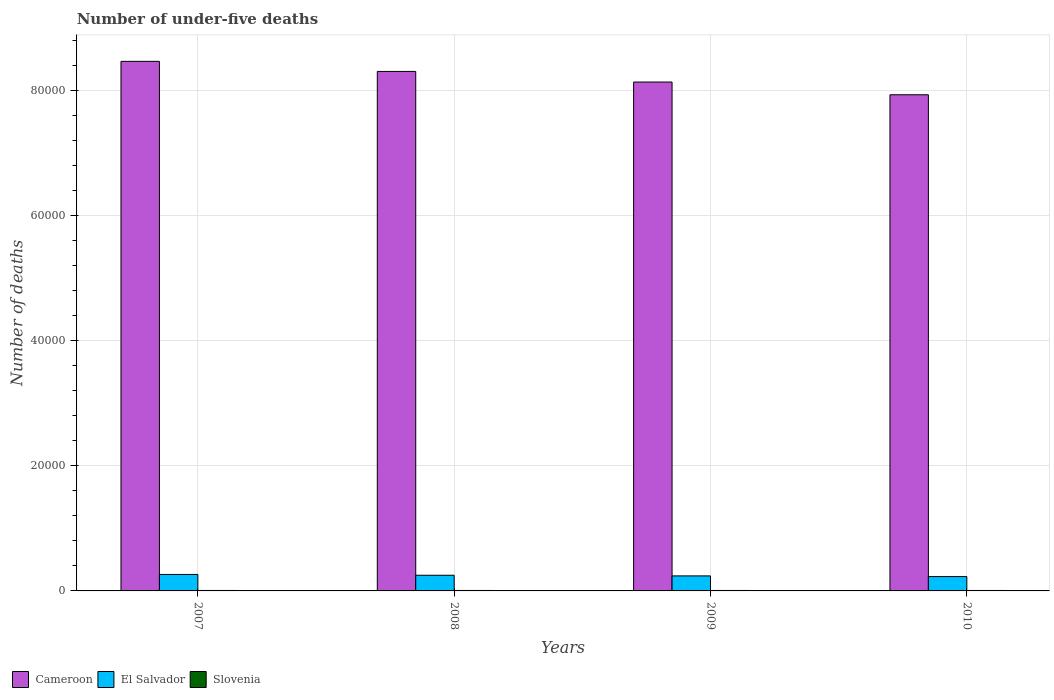How many different coloured bars are there?
Give a very brief answer. 3. How many groups of bars are there?
Your response must be concise. 4. Are the number of bars on each tick of the X-axis equal?
Give a very brief answer. Yes. How many bars are there on the 2nd tick from the left?
Provide a short and direct response. 3. What is the label of the 1st group of bars from the left?
Your response must be concise. 2007. In how many cases, is the number of bars for a given year not equal to the number of legend labels?
Give a very brief answer. 0. Across all years, what is the maximum number of under-five deaths in Cameroon?
Keep it short and to the point. 8.47e+04. Across all years, what is the minimum number of under-five deaths in Cameroon?
Provide a succinct answer. 7.93e+04. In which year was the number of under-five deaths in El Salvador maximum?
Provide a short and direct response. 2007. In which year was the number of under-five deaths in Slovenia minimum?
Provide a short and direct response. 2010. What is the total number of under-five deaths in Cameroon in the graph?
Ensure brevity in your answer.  3.28e+05. What is the difference between the number of under-five deaths in El Salvador in 2008 and that in 2009?
Your answer should be very brief. 103. What is the difference between the number of under-five deaths in Slovenia in 2010 and the number of under-five deaths in Cameroon in 2009?
Give a very brief answer. -8.13e+04. In the year 2009, what is the difference between the number of under-five deaths in El Salvador and number of under-five deaths in Cameroon?
Ensure brevity in your answer.  -7.90e+04. In how many years, is the number of under-five deaths in El Salvador greater than 56000?
Ensure brevity in your answer.  0. What is the ratio of the number of under-five deaths in El Salvador in 2007 to that in 2009?
Offer a very short reply. 1.1. Is the number of under-five deaths in Cameroon in 2008 less than that in 2010?
Your answer should be compact. No. Is the difference between the number of under-five deaths in El Salvador in 2009 and 2010 greater than the difference between the number of under-five deaths in Cameroon in 2009 and 2010?
Your answer should be compact. No. What is the difference between the highest and the second highest number of under-five deaths in Cameroon?
Offer a very short reply. 1611. What is the difference between the highest and the lowest number of under-five deaths in Cameroon?
Provide a short and direct response. 5342. What does the 3rd bar from the left in 2009 represents?
Make the answer very short. Slovenia. What does the 3rd bar from the right in 2010 represents?
Provide a short and direct response. Cameroon. How many bars are there?
Provide a short and direct response. 12. Are all the bars in the graph horizontal?
Your answer should be compact. No. What is the difference between two consecutive major ticks on the Y-axis?
Your answer should be very brief. 2.00e+04. Are the values on the major ticks of Y-axis written in scientific E-notation?
Make the answer very short. No. Does the graph contain any zero values?
Keep it short and to the point. No. Does the graph contain grids?
Your response must be concise. Yes. Where does the legend appear in the graph?
Offer a very short reply. Bottom left. How are the legend labels stacked?
Offer a very short reply. Horizontal. What is the title of the graph?
Provide a succinct answer. Number of under-five deaths. Does "Israel" appear as one of the legend labels in the graph?
Offer a terse response. No. What is the label or title of the X-axis?
Make the answer very short. Years. What is the label or title of the Y-axis?
Offer a terse response. Number of deaths. What is the Number of deaths in Cameroon in 2007?
Give a very brief answer. 8.47e+04. What is the Number of deaths in El Salvador in 2007?
Offer a terse response. 2633. What is the Number of deaths of Slovenia in 2007?
Provide a succinct answer. 73. What is the Number of deaths of Cameroon in 2008?
Provide a short and direct response. 8.31e+04. What is the Number of deaths in El Salvador in 2008?
Keep it short and to the point. 2505. What is the Number of deaths in Slovenia in 2008?
Keep it short and to the point. 73. What is the Number of deaths of Cameroon in 2009?
Provide a succinct answer. 8.14e+04. What is the Number of deaths in El Salvador in 2009?
Provide a short and direct response. 2402. What is the Number of deaths of Cameroon in 2010?
Ensure brevity in your answer.  7.93e+04. What is the Number of deaths of El Salvador in 2010?
Provide a short and direct response. 2291. Across all years, what is the maximum Number of deaths in Cameroon?
Provide a short and direct response. 8.47e+04. Across all years, what is the maximum Number of deaths in El Salvador?
Ensure brevity in your answer.  2633. Across all years, what is the maximum Number of deaths in Slovenia?
Make the answer very short. 74. Across all years, what is the minimum Number of deaths in Cameroon?
Your response must be concise. 7.93e+04. Across all years, what is the minimum Number of deaths of El Salvador?
Provide a succinct answer. 2291. What is the total Number of deaths of Cameroon in the graph?
Provide a short and direct response. 3.28e+05. What is the total Number of deaths in El Salvador in the graph?
Give a very brief answer. 9831. What is the total Number of deaths of Slovenia in the graph?
Your answer should be very brief. 292. What is the difference between the Number of deaths in Cameroon in 2007 and that in 2008?
Your response must be concise. 1611. What is the difference between the Number of deaths in El Salvador in 2007 and that in 2008?
Ensure brevity in your answer.  128. What is the difference between the Number of deaths in Slovenia in 2007 and that in 2008?
Keep it short and to the point. 0. What is the difference between the Number of deaths in Cameroon in 2007 and that in 2009?
Your answer should be very brief. 3306. What is the difference between the Number of deaths in El Salvador in 2007 and that in 2009?
Offer a very short reply. 231. What is the difference between the Number of deaths of Slovenia in 2007 and that in 2009?
Make the answer very short. -1. What is the difference between the Number of deaths of Cameroon in 2007 and that in 2010?
Keep it short and to the point. 5342. What is the difference between the Number of deaths of El Salvador in 2007 and that in 2010?
Your answer should be very brief. 342. What is the difference between the Number of deaths of Slovenia in 2007 and that in 2010?
Provide a short and direct response. 1. What is the difference between the Number of deaths in Cameroon in 2008 and that in 2009?
Your answer should be compact. 1695. What is the difference between the Number of deaths of El Salvador in 2008 and that in 2009?
Ensure brevity in your answer.  103. What is the difference between the Number of deaths of Slovenia in 2008 and that in 2009?
Give a very brief answer. -1. What is the difference between the Number of deaths of Cameroon in 2008 and that in 2010?
Ensure brevity in your answer.  3731. What is the difference between the Number of deaths in El Salvador in 2008 and that in 2010?
Offer a terse response. 214. What is the difference between the Number of deaths in Cameroon in 2009 and that in 2010?
Offer a terse response. 2036. What is the difference between the Number of deaths in El Salvador in 2009 and that in 2010?
Keep it short and to the point. 111. What is the difference between the Number of deaths in Slovenia in 2009 and that in 2010?
Ensure brevity in your answer.  2. What is the difference between the Number of deaths of Cameroon in 2007 and the Number of deaths of El Salvador in 2008?
Make the answer very short. 8.22e+04. What is the difference between the Number of deaths in Cameroon in 2007 and the Number of deaths in Slovenia in 2008?
Your answer should be compact. 8.46e+04. What is the difference between the Number of deaths of El Salvador in 2007 and the Number of deaths of Slovenia in 2008?
Give a very brief answer. 2560. What is the difference between the Number of deaths of Cameroon in 2007 and the Number of deaths of El Salvador in 2009?
Provide a short and direct response. 8.23e+04. What is the difference between the Number of deaths of Cameroon in 2007 and the Number of deaths of Slovenia in 2009?
Give a very brief answer. 8.46e+04. What is the difference between the Number of deaths in El Salvador in 2007 and the Number of deaths in Slovenia in 2009?
Offer a terse response. 2559. What is the difference between the Number of deaths in Cameroon in 2007 and the Number of deaths in El Salvador in 2010?
Make the answer very short. 8.24e+04. What is the difference between the Number of deaths of Cameroon in 2007 and the Number of deaths of Slovenia in 2010?
Your answer should be compact. 8.46e+04. What is the difference between the Number of deaths in El Salvador in 2007 and the Number of deaths in Slovenia in 2010?
Provide a short and direct response. 2561. What is the difference between the Number of deaths in Cameroon in 2008 and the Number of deaths in El Salvador in 2009?
Your answer should be compact. 8.07e+04. What is the difference between the Number of deaths of Cameroon in 2008 and the Number of deaths of Slovenia in 2009?
Give a very brief answer. 8.30e+04. What is the difference between the Number of deaths of El Salvador in 2008 and the Number of deaths of Slovenia in 2009?
Ensure brevity in your answer.  2431. What is the difference between the Number of deaths of Cameroon in 2008 and the Number of deaths of El Salvador in 2010?
Your answer should be compact. 8.08e+04. What is the difference between the Number of deaths in Cameroon in 2008 and the Number of deaths in Slovenia in 2010?
Provide a short and direct response. 8.30e+04. What is the difference between the Number of deaths in El Salvador in 2008 and the Number of deaths in Slovenia in 2010?
Your answer should be very brief. 2433. What is the difference between the Number of deaths in Cameroon in 2009 and the Number of deaths in El Salvador in 2010?
Your answer should be compact. 7.91e+04. What is the difference between the Number of deaths of Cameroon in 2009 and the Number of deaths of Slovenia in 2010?
Provide a short and direct response. 8.13e+04. What is the difference between the Number of deaths of El Salvador in 2009 and the Number of deaths of Slovenia in 2010?
Your answer should be very brief. 2330. What is the average Number of deaths of Cameroon per year?
Offer a very short reply. 8.21e+04. What is the average Number of deaths in El Salvador per year?
Your answer should be very brief. 2457.75. In the year 2007, what is the difference between the Number of deaths of Cameroon and Number of deaths of El Salvador?
Provide a short and direct response. 8.20e+04. In the year 2007, what is the difference between the Number of deaths of Cameroon and Number of deaths of Slovenia?
Your answer should be compact. 8.46e+04. In the year 2007, what is the difference between the Number of deaths of El Salvador and Number of deaths of Slovenia?
Ensure brevity in your answer.  2560. In the year 2008, what is the difference between the Number of deaths of Cameroon and Number of deaths of El Salvador?
Your response must be concise. 8.05e+04. In the year 2008, what is the difference between the Number of deaths in Cameroon and Number of deaths in Slovenia?
Offer a terse response. 8.30e+04. In the year 2008, what is the difference between the Number of deaths of El Salvador and Number of deaths of Slovenia?
Make the answer very short. 2432. In the year 2009, what is the difference between the Number of deaths of Cameroon and Number of deaths of El Salvador?
Your answer should be very brief. 7.90e+04. In the year 2009, what is the difference between the Number of deaths of Cameroon and Number of deaths of Slovenia?
Your answer should be very brief. 8.13e+04. In the year 2009, what is the difference between the Number of deaths of El Salvador and Number of deaths of Slovenia?
Give a very brief answer. 2328. In the year 2010, what is the difference between the Number of deaths of Cameroon and Number of deaths of El Salvador?
Offer a terse response. 7.70e+04. In the year 2010, what is the difference between the Number of deaths in Cameroon and Number of deaths in Slovenia?
Your answer should be very brief. 7.93e+04. In the year 2010, what is the difference between the Number of deaths of El Salvador and Number of deaths of Slovenia?
Your response must be concise. 2219. What is the ratio of the Number of deaths in Cameroon in 2007 to that in 2008?
Your response must be concise. 1.02. What is the ratio of the Number of deaths of El Salvador in 2007 to that in 2008?
Ensure brevity in your answer.  1.05. What is the ratio of the Number of deaths of Cameroon in 2007 to that in 2009?
Keep it short and to the point. 1.04. What is the ratio of the Number of deaths of El Salvador in 2007 to that in 2009?
Provide a short and direct response. 1.1. What is the ratio of the Number of deaths in Slovenia in 2007 to that in 2009?
Offer a very short reply. 0.99. What is the ratio of the Number of deaths of Cameroon in 2007 to that in 2010?
Provide a short and direct response. 1.07. What is the ratio of the Number of deaths of El Salvador in 2007 to that in 2010?
Offer a very short reply. 1.15. What is the ratio of the Number of deaths in Slovenia in 2007 to that in 2010?
Offer a very short reply. 1.01. What is the ratio of the Number of deaths in Cameroon in 2008 to that in 2009?
Give a very brief answer. 1.02. What is the ratio of the Number of deaths of El Salvador in 2008 to that in 2009?
Provide a succinct answer. 1.04. What is the ratio of the Number of deaths of Slovenia in 2008 to that in 2009?
Keep it short and to the point. 0.99. What is the ratio of the Number of deaths of Cameroon in 2008 to that in 2010?
Your answer should be compact. 1.05. What is the ratio of the Number of deaths in El Salvador in 2008 to that in 2010?
Your response must be concise. 1.09. What is the ratio of the Number of deaths in Slovenia in 2008 to that in 2010?
Offer a very short reply. 1.01. What is the ratio of the Number of deaths in Cameroon in 2009 to that in 2010?
Your answer should be very brief. 1.03. What is the ratio of the Number of deaths in El Salvador in 2009 to that in 2010?
Give a very brief answer. 1.05. What is the ratio of the Number of deaths in Slovenia in 2009 to that in 2010?
Ensure brevity in your answer.  1.03. What is the difference between the highest and the second highest Number of deaths in Cameroon?
Give a very brief answer. 1611. What is the difference between the highest and the second highest Number of deaths of El Salvador?
Offer a very short reply. 128. What is the difference between the highest and the lowest Number of deaths in Cameroon?
Offer a terse response. 5342. What is the difference between the highest and the lowest Number of deaths in El Salvador?
Offer a very short reply. 342. What is the difference between the highest and the lowest Number of deaths in Slovenia?
Keep it short and to the point. 2. 